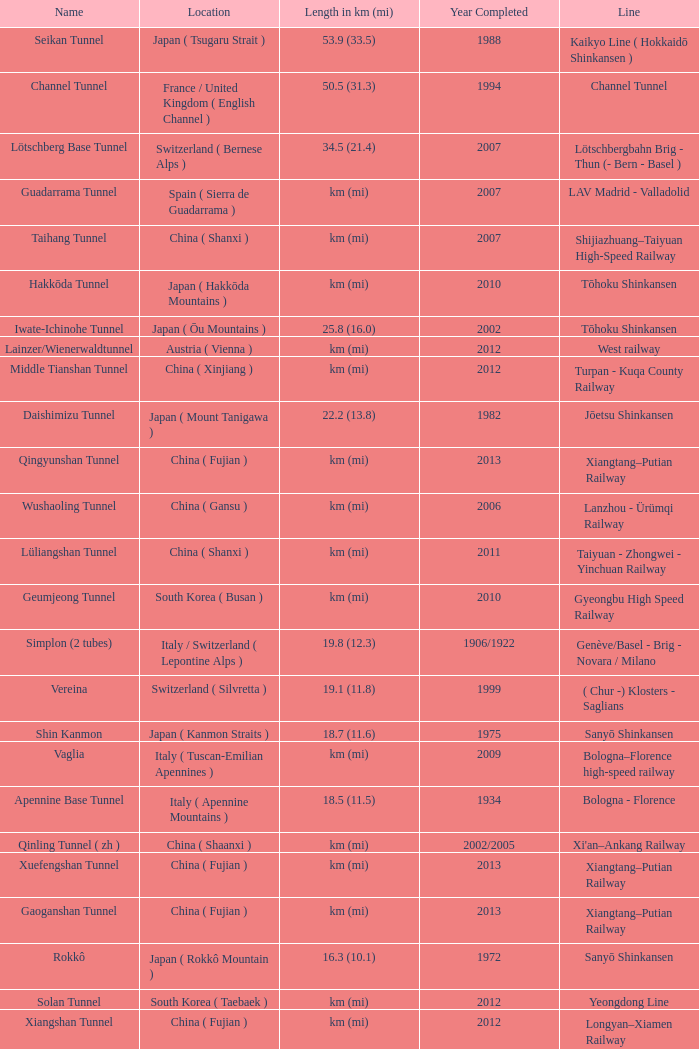In which year was the gardermobanen line finished? 1999.0. 